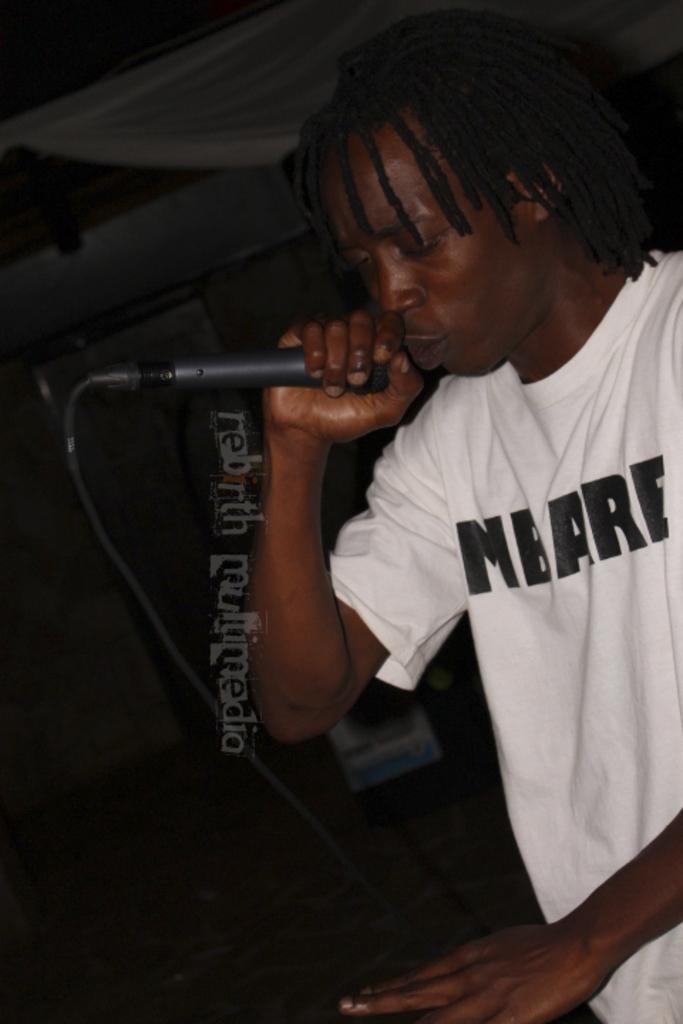How would you summarize this image in a sentence or two? In this image we can see a person holding a mic and there are some objects, at the top we can see the roof. 